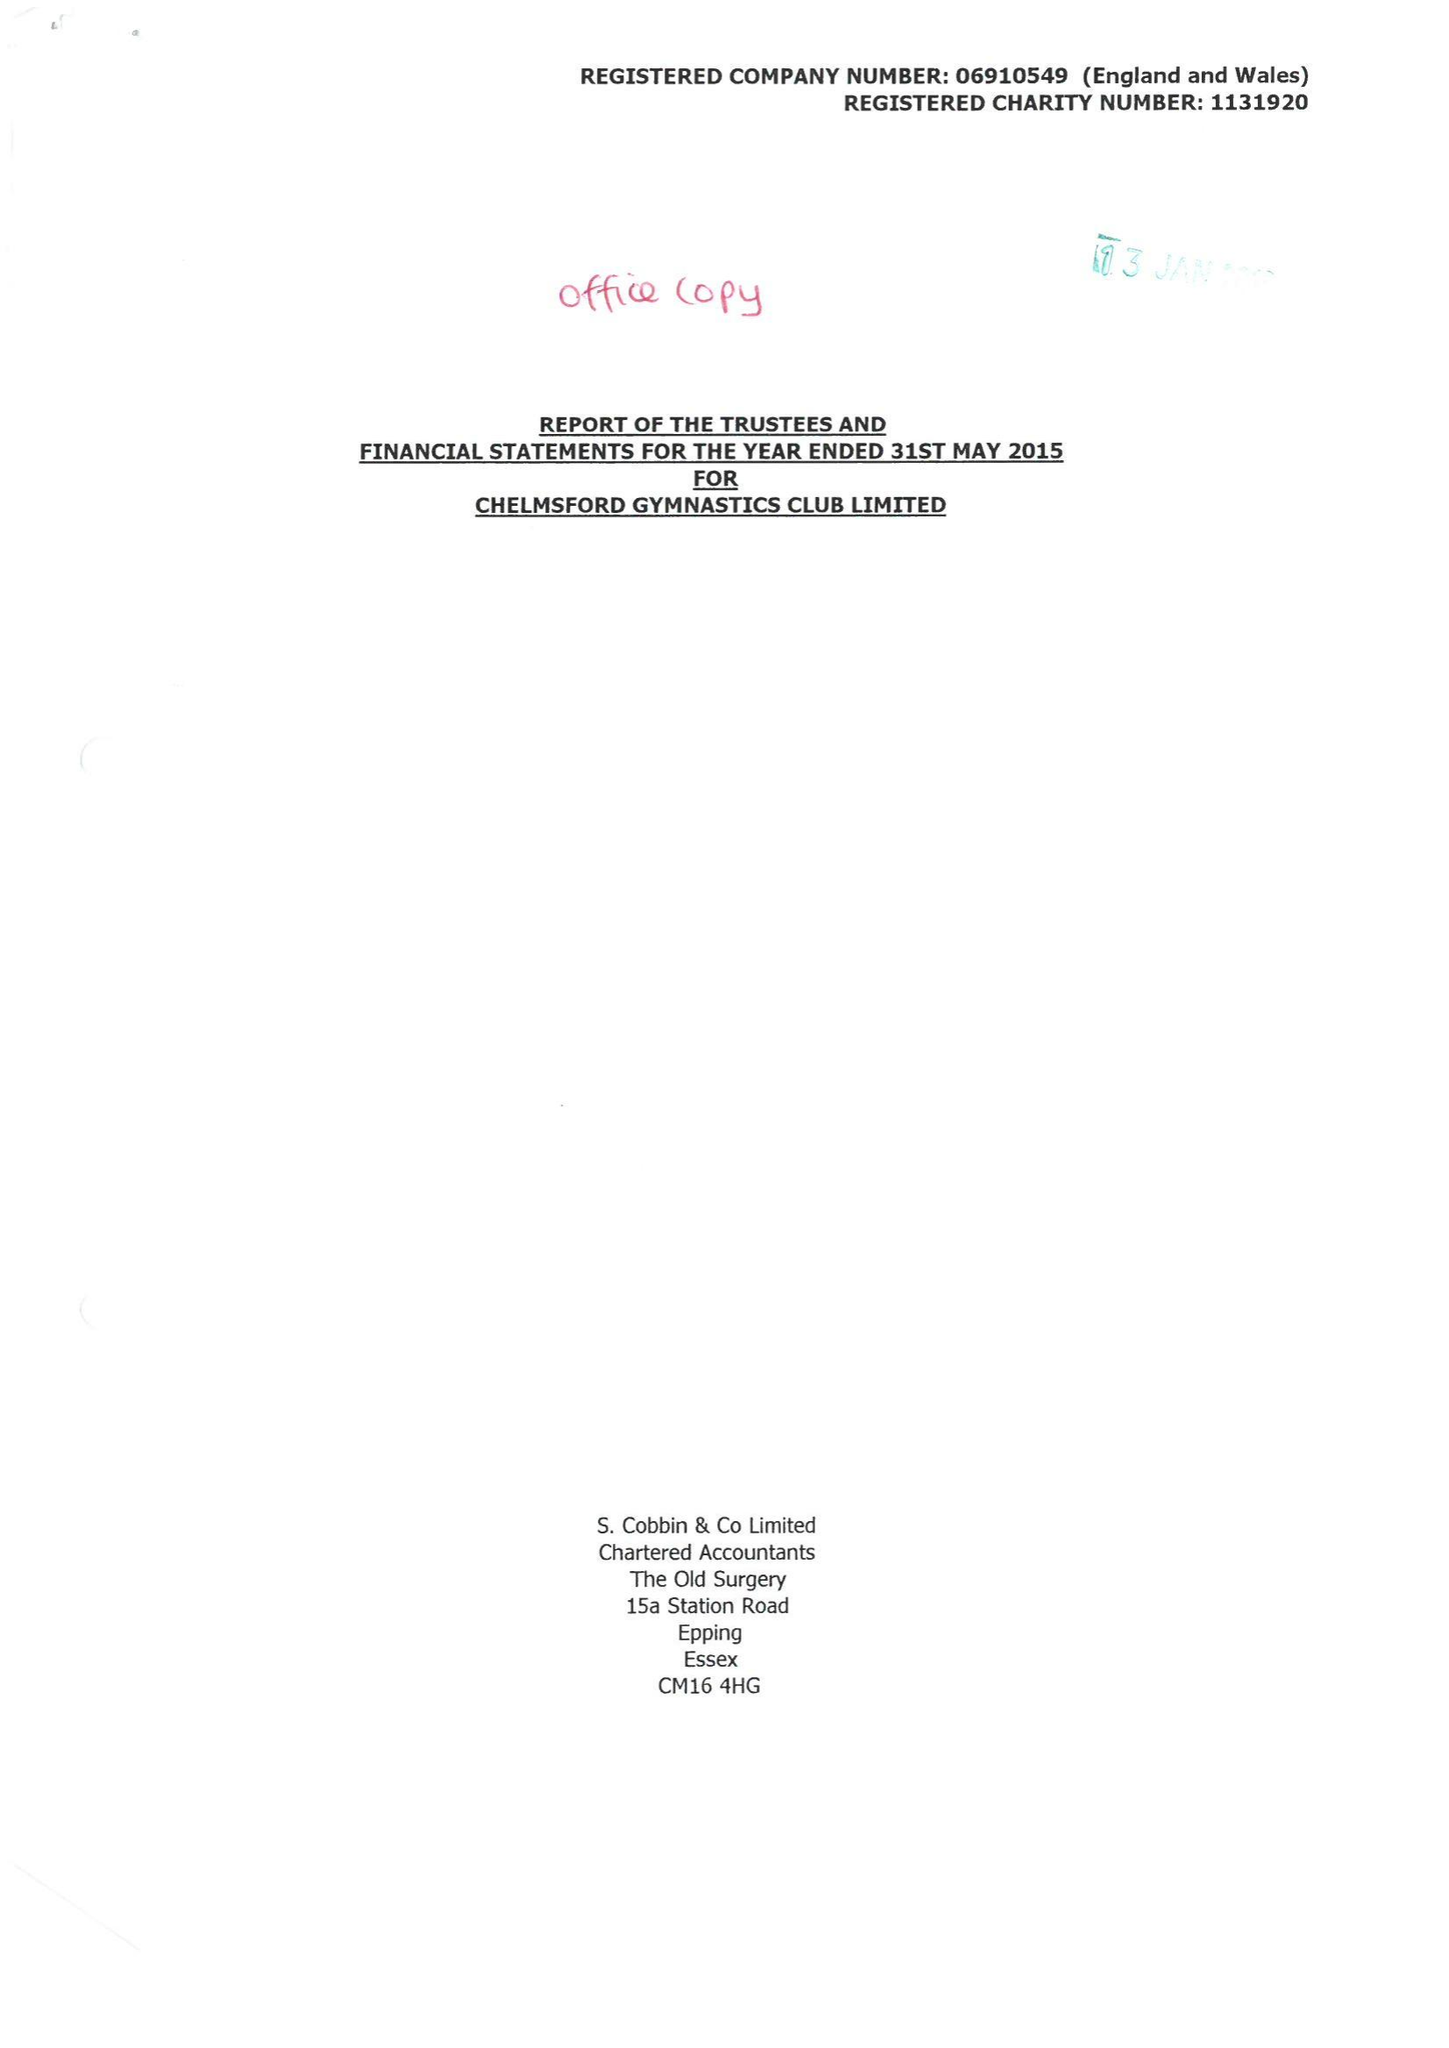What is the value for the charity_name?
Answer the question using a single word or phrase. Chelmsford Gymnastics Club Ltd. 